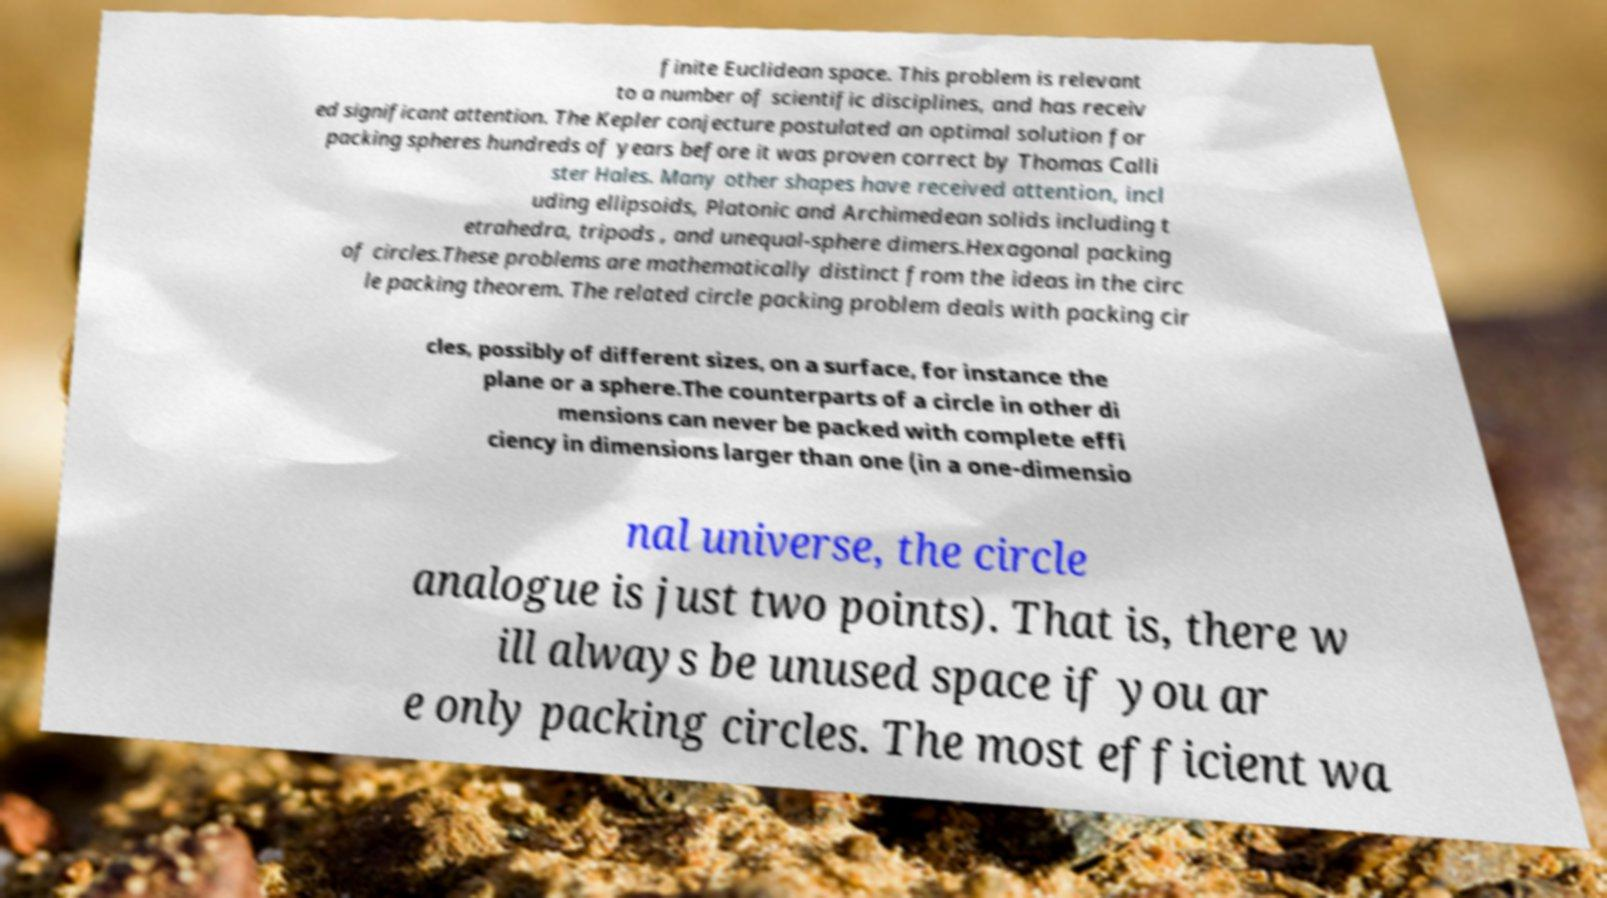Could you assist in decoding the text presented in this image and type it out clearly? finite Euclidean space. This problem is relevant to a number of scientific disciplines, and has receiv ed significant attention. The Kepler conjecture postulated an optimal solution for packing spheres hundreds of years before it was proven correct by Thomas Calli ster Hales. Many other shapes have received attention, incl uding ellipsoids, Platonic and Archimedean solids including t etrahedra, tripods , and unequal-sphere dimers.Hexagonal packing of circles.These problems are mathematically distinct from the ideas in the circ le packing theorem. The related circle packing problem deals with packing cir cles, possibly of different sizes, on a surface, for instance the plane or a sphere.The counterparts of a circle in other di mensions can never be packed with complete effi ciency in dimensions larger than one (in a one-dimensio nal universe, the circle analogue is just two points). That is, there w ill always be unused space if you ar e only packing circles. The most efficient wa 